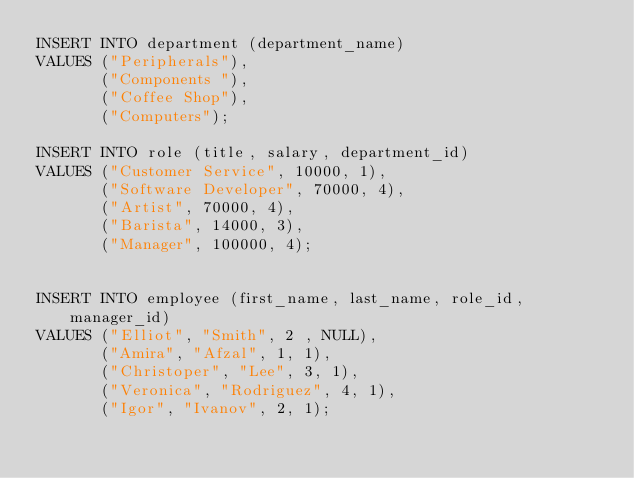<code> <loc_0><loc_0><loc_500><loc_500><_SQL_>INSERT INTO department (department_name)
VALUES ("Peripherals"),
       ("Components "),
       ("Coffee Shop"),
       ("Computers");

INSERT INTO role (title, salary, department_id)
VALUES ("Customer Service", 10000, 1),
       ("Software Developer", 70000, 4),
       ("Artist", 70000, 4),
       ("Barista", 14000, 3),
       ("Manager", 100000, 4);


INSERT INTO employee (first_name, last_name, role_id, manager_id)
VALUES ("Elliot", "Smith", 2 , NULL),
       ("Amira", "Afzal", 1, 1),
       ("Christoper", "Lee", 3, 1),
       ("Veronica", "Rodriguez", 4, 1),
       ("Igor", "Ivanov", 2, 1);</code> 